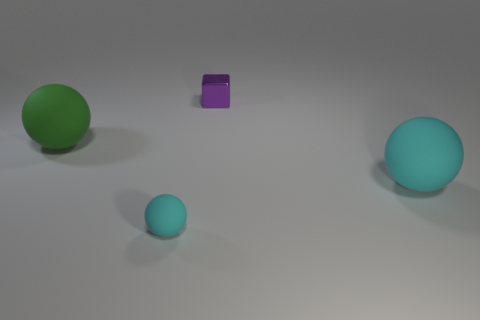Add 2 tiny cyan matte objects. How many objects exist? 6 Subtract all blocks. How many objects are left? 3 Subtract 1 green balls. How many objects are left? 3 Subtract all tiny purple metallic things. Subtract all small cyan rubber cylinders. How many objects are left? 3 Add 1 big rubber balls. How many big rubber balls are left? 3 Add 2 cyan rubber things. How many cyan rubber things exist? 4 